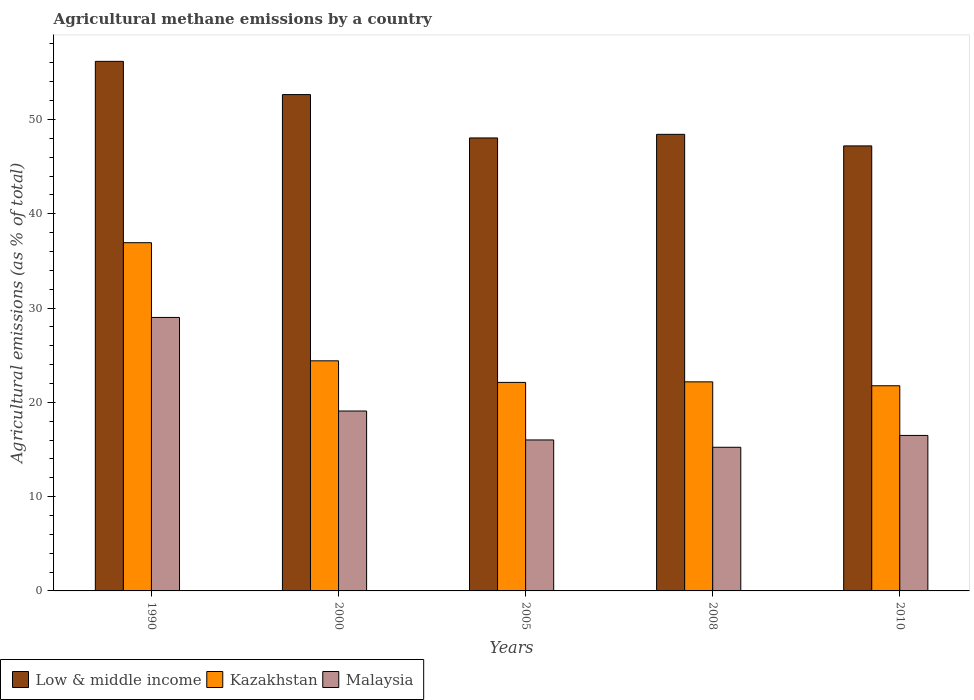How many bars are there on the 4th tick from the right?
Provide a succinct answer. 3. What is the label of the 5th group of bars from the left?
Offer a terse response. 2010. In how many cases, is the number of bars for a given year not equal to the number of legend labels?
Ensure brevity in your answer.  0. What is the amount of agricultural methane emitted in Malaysia in 2000?
Your answer should be compact. 19.08. Across all years, what is the maximum amount of agricultural methane emitted in Kazakhstan?
Offer a very short reply. 36.93. Across all years, what is the minimum amount of agricultural methane emitted in Malaysia?
Your answer should be very brief. 15.23. In which year was the amount of agricultural methane emitted in Malaysia minimum?
Give a very brief answer. 2008. What is the total amount of agricultural methane emitted in Malaysia in the graph?
Provide a short and direct response. 95.81. What is the difference between the amount of agricultural methane emitted in Kazakhstan in 1990 and that in 2005?
Offer a very short reply. 14.82. What is the difference between the amount of agricultural methane emitted in Malaysia in 2008 and the amount of agricultural methane emitted in Kazakhstan in 2010?
Make the answer very short. -6.52. What is the average amount of agricultural methane emitted in Low & middle income per year?
Offer a very short reply. 50.49. In the year 2000, what is the difference between the amount of agricultural methane emitted in Low & middle income and amount of agricultural methane emitted in Kazakhstan?
Offer a very short reply. 28.23. In how many years, is the amount of agricultural methane emitted in Low & middle income greater than 2 %?
Keep it short and to the point. 5. What is the ratio of the amount of agricultural methane emitted in Malaysia in 1990 to that in 2000?
Your answer should be very brief. 1.52. Is the amount of agricultural methane emitted in Malaysia in 1990 less than that in 2005?
Make the answer very short. No. What is the difference between the highest and the second highest amount of agricultural methane emitted in Kazakhstan?
Provide a short and direct response. 12.53. What is the difference between the highest and the lowest amount of agricultural methane emitted in Malaysia?
Give a very brief answer. 13.77. In how many years, is the amount of agricultural methane emitted in Malaysia greater than the average amount of agricultural methane emitted in Malaysia taken over all years?
Offer a terse response. 1. Is the sum of the amount of agricultural methane emitted in Low & middle income in 2005 and 2008 greater than the maximum amount of agricultural methane emitted in Kazakhstan across all years?
Give a very brief answer. Yes. What does the 3rd bar from the left in 2010 represents?
Ensure brevity in your answer.  Malaysia. What does the 2nd bar from the right in 2005 represents?
Keep it short and to the point. Kazakhstan. Is it the case that in every year, the sum of the amount of agricultural methane emitted in Malaysia and amount of agricultural methane emitted in Low & middle income is greater than the amount of agricultural methane emitted in Kazakhstan?
Provide a succinct answer. Yes. How many bars are there?
Offer a terse response. 15. Are all the bars in the graph horizontal?
Ensure brevity in your answer.  No. How many years are there in the graph?
Your answer should be compact. 5. Does the graph contain any zero values?
Offer a terse response. No. Does the graph contain grids?
Offer a terse response. No. How many legend labels are there?
Your answer should be very brief. 3. What is the title of the graph?
Make the answer very short. Agricultural methane emissions by a country. Does "High income" appear as one of the legend labels in the graph?
Keep it short and to the point. No. What is the label or title of the X-axis?
Give a very brief answer. Years. What is the label or title of the Y-axis?
Your answer should be very brief. Agricultural emissions (as % of total). What is the Agricultural emissions (as % of total) of Low & middle income in 1990?
Ensure brevity in your answer.  56.16. What is the Agricultural emissions (as % of total) in Kazakhstan in 1990?
Give a very brief answer. 36.93. What is the Agricultural emissions (as % of total) of Malaysia in 1990?
Offer a terse response. 29. What is the Agricultural emissions (as % of total) of Low & middle income in 2000?
Give a very brief answer. 52.63. What is the Agricultural emissions (as % of total) of Kazakhstan in 2000?
Offer a very short reply. 24.4. What is the Agricultural emissions (as % of total) of Malaysia in 2000?
Make the answer very short. 19.08. What is the Agricultural emissions (as % of total) of Low & middle income in 2005?
Provide a succinct answer. 48.04. What is the Agricultural emissions (as % of total) of Kazakhstan in 2005?
Provide a short and direct response. 22.11. What is the Agricultural emissions (as % of total) in Malaysia in 2005?
Give a very brief answer. 16.01. What is the Agricultural emissions (as % of total) in Low & middle income in 2008?
Give a very brief answer. 48.42. What is the Agricultural emissions (as % of total) of Kazakhstan in 2008?
Give a very brief answer. 22.17. What is the Agricultural emissions (as % of total) of Malaysia in 2008?
Your response must be concise. 15.23. What is the Agricultural emissions (as % of total) of Low & middle income in 2010?
Provide a short and direct response. 47.19. What is the Agricultural emissions (as % of total) of Kazakhstan in 2010?
Ensure brevity in your answer.  21.76. What is the Agricultural emissions (as % of total) of Malaysia in 2010?
Make the answer very short. 16.49. Across all years, what is the maximum Agricultural emissions (as % of total) of Low & middle income?
Ensure brevity in your answer.  56.16. Across all years, what is the maximum Agricultural emissions (as % of total) of Kazakhstan?
Offer a very short reply. 36.93. Across all years, what is the maximum Agricultural emissions (as % of total) in Malaysia?
Your answer should be compact. 29. Across all years, what is the minimum Agricultural emissions (as % of total) of Low & middle income?
Your answer should be very brief. 47.19. Across all years, what is the minimum Agricultural emissions (as % of total) of Kazakhstan?
Your answer should be very brief. 21.76. Across all years, what is the minimum Agricultural emissions (as % of total) of Malaysia?
Ensure brevity in your answer.  15.23. What is the total Agricultural emissions (as % of total) in Low & middle income in the graph?
Give a very brief answer. 252.44. What is the total Agricultural emissions (as % of total) in Kazakhstan in the graph?
Make the answer very short. 127.37. What is the total Agricultural emissions (as % of total) of Malaysia in the graph?
Make the answer very short. 95.81. What is the difference between the Agricultural emissions (as % of total) in Low & middle income in 1990 and that in 2000?
Your answer should be compact. 3.52. What is the difference between the Agricultural emissions (as % of total) in Kazakhstan in 1990 and that in 2000?
Your answer should be compact. 12.53. What is the difference between the Agricultural emissions (as % of total) in Malaysia in 1990 and that in 2000?
Ensure brevity in your answer.  9.92. What is the difference between the Agricultural emissions (as % of total) of Low & middle income in 1990 and that in 2005?
Offer a very short reply. 8.12. What is the difference between the Agricultural emissions (as % of total) of Kazakhstan in 1990 and that in 2005?
Offer a terse response. 14.82. What is the difference between the Agricultural emissions (as % of total) of Malaysia in 1990 and that in 2005?
Provide a short and direct response. 12.99. What is the difference between the Agricultural emissions (as % of total) of Low & middle income in 1990 and that in 2008?
Give a very brief answer. 7.74. What is the difference between the Agricultural emissions (as % of total) of Kazakhstan in 1990 and that in 2008?
Your answer should be very brief. 14.76. What is the difference between the Agricultural emissions (as % of total) in Malaysia in 1990 and that in 2008?
Provide a succinct answer. 13.77. What is the difference between the Agricultural emissions (as % of total) in Low & middle income in 1990 and that in 2010?
Your response must be concise. 8.97. What is the difference between the Agricultural emissions (as % of total) of Kazakhstan in 1990 and that in 2010?
Give a very brief answer. 15.17. What is the difference between the Agricultural emissions (as % of total) in Malaysia in 1990 and that in 2010?
Keep it short and to the point. 12.51. What is the difference between the Agricultural emissions (as % of total) of Low & middle income in 2000 and that in 2005?
Keep it short and to the point. 4.6. What is the difference between the Agricultural emissions (as % of total) in Kazakhstan in 2000 and that in 2005?
Your answer should be very brief. 2.29. What is the difference between the Agricultural emissions (as % of total) of Malaysia in 2000 and that in 2005?
Provide a short and direct response. 3.07. What is the difference between the Agricultural emissions (as % of total) in Low & middle income in 2000 and that in 2008?
Provide a short and direct response. 4.22. What is the difference between the Agricultural emissions (as % of total) in Kazakhstan in 2000 and that in 2008?
Provide a succinct answer. 2.23. What is the difference between the Agricultural emissions (as % of total) in Malaysia in 2000 and that in 2008?
Make the answer very short. 3.85. What is the difference between the Agricultural emissions (as % of total) of Low & middle income in 2000 and that in 2010?
Your answer should be very brief. 5.44. What is the difference between the Agricultural emissions (as % of total) of Kazakhstan in 2000 and that in 2010?
Give a very brief answer. 2.64. What is the difference between the Agricultural emissions (as % of total) of Malaysia in 2000 and that in 2010?
Offer a very short reply. 2.59. What is the difference between the Agricultural emissions (as % of total) of Low & middle income in 2005 and that in 2008?
Provide a short and direct response. -0.38. What is the difference between the Agricultural emissions (as % of total) of Kazakhstan in 2005 and that in 2008?
Give a very brief answer. -0.06. What is the difference between the Agricultural emissions (as % of total) in Malaysia in 2005 and that in 2008?
Offer a very short reply. 0.78. What is the difference between the Agricultural emissions (as % of total) in Low & middle income in 2005 and that in 2010?
Give a very brief answer. 0.84. What is the difference between the Agricultural emissions (as % of total) of Kazakhstan in 2005 and that in 2010?
Give a very brief answer. 0.36. What is the difference between the Agricultural emissions (as % of total) in Malaysia in 2005 and that in 2010?
Provide a succinct answer. -0.48. What is the difference between the Agricultural emissions (as % of total) in Low & middle income in 2008 and that in 2010?
Make the answer very short. 1.23. What is the difference between the Agricultural emissions (as % of total) in Kazakhstan in 2008 and that in 2010?
Your answer should be very brief. 0.41. What is the difference between the Agricultural emissions (as % of total) of Malaysia in 2008 and that in 2010?
Ensure brevity in your answer.  -1.26. What is the difference between the Agricultural emissions (as % of total) of Low & middle income in 1990 and the Agricultural emissions (as % of total) of Kazakhstan in 2000?
Give a very brief answer. 31.76. What is the difference between the Agricultural emissions (as % of total) of Low & middle income in 1990 and the Agricultural emissions (as % of total) of Malaysia in 2000?
Your response must be concise. 37.08. What is the difference between the Agricultural emissions (as % of total) in Kazakhstan in 1990 and the Agricultural emissions (as % of total) in Malaysia in 2000?
Provide a succinct answer. 17.85. What is the difference between the Agricultural emissions (as % of total) of Low & middle income in 1990 and the Agricultural emissions (as % of total) of Kazakhstan in 2005?
Keep it short and to the point. 34.05. What is the difference between the Agricultural emissions (as % of total) in Low & middle income in 1990 and the Agricultural emissions (as % of total) in Malaysia in 2005?
Keep it short and to the point. 40.15. What is the difference between the Agricultural emissions (as % of total) of Kazakhstan in 1990 and the Agricultural emissions (as % of total) of Malaysia in 2005?
Offer a very short reply. 20.92. What is the difference between the Agricultural emissions (as % of total) in Low & middle income in 1990 and the Agricultural emissions (as % of total) in Kazakhstan in 2008?
Offer a very short reply. 33.99. What is the difference between the Agricultural emissions (as % of total) in Low & middle income in 1990 and the Agricultural emissions (as % of total) in Malaysia in 2008?
Keep it short and to the point. 40.93. What is the difference between the Agricultural emissions (as % of total) in Kazakhstan in 1990 and the Agricultural emissions (as % of total) in Malaysia in 2008?
Your answer should be compact. 21.69. What is the difference between the Agricultural emissions (as % of total) in Low & middle income in 1990 and the Agricultural emissions (as % of total) in Kazakhstan in 2010?
Give a very brief answer. 34.4. What is the difference between the Agricultural emissions (as % of total) of Low & middle income in 1990 and the Agricultural emissions (as % of total) of Malaysia in 2010?
Provide a succinct answer. 39.67. What is the difference between the Agricultural emissions (as % of total) in Kazakhstan in 1990 and the Agricultural emissions (as % of total) in Malaysia in 2010?
Your response must be concise. 20.44. What is the difference between the Agricultural emissions (as % of total) in Low & middle income in 2000 and the Agricultural emissions (as % of total) in Kazakhstan in 2005?
Ensure brevity in your answer.  30.52. What is the difference between the Agricultural emissions (as % of total) in Low & middle income in 2000 and the Agricultural emissions (as % of total) in Malaysia in 2005?
Your answer should be compact. 36.62. What is the difference between the Agricultural emissions (as % of total) of Kazakhstan in 2000 and the Agricultural emissions (as % of total) of Malaysia in 2005?
Keep it short and to the point. 8.39. What is the difference between the Agricultural emissions (as % of total) in Low & middle income in 2000 and the Agricultural emissions (as % of total) in Kazakhstan in 2008?
Your answer should be compact. 30.46. What is the difference between the Agricultural emissions (as % of total) of Low & middle income in 2000 and the Agricultural emissions (as % of total) of Malaysia in 2008?
Provide a short and direct response. 37.4. What is the difference between the Agricultural emissions (as % of total) in Kazakhstan in 2000 and the Agricultural emissions (as % of total) in Malaysia in 2008?
Give a very brief answer. 9.17. What is the difference between the Agricultural emissions (as % of total) in Low & middle income in 2000 and the Agricultural emissions (as % of total) in Kazakhstan in 2010?
Your response must be concise. 30.88. What is the difference between the Agricultural emissions (as % of total) of Low & middle income in 2000 and the Agricultural emissions (as % of total) of Malaysia in 2010?
Give a very brief answer. 36.15. What is the difference between the Agricultural emissions (as % of total) of Kazakhstan in 2000 and the Agricultural emissions (as % of total) of Malaysia in 2010?
Make the answer very short. 7.91. What is the difference between the Agricultural emissions (as % of total) in Low & middle income in 2005 and the Agricultural emissions (as % of total) in Kazakhstan in 2008?
Your answer should be compact. 25.87. What is the difference between the Agricultural emissions (as % of total) in Low & middle income in 2005 and the Agricultural emissions (as % of total) in Malaysia in 2008?
Ensure brevity in your answer.  32.8. What is the difference between the Agricultural emissions (as % of total) in Kazakhstan in 2005 and the Agricultural emissions (as % of total) in Malaysia in 2008?
Provide a short and direct response. 6.88. What is the difference between the Agricultural emissions (as % of total) in Low & middle income in 2005 and the Agricultural emissions (as % of total) in Kazakhstan in 2010?
Provide a short and direct response. 26.28. What is the difference between the Agricultural emissions (as % of total) of Low & middle income in 2005 and the Agricultural emissions (as % of total) of Malaysia in 2010?
Your answer should be compact. 31.55. What is the difference between the Agricultural emissions (as % of total) of Kazakhstan in 2005 and the Agricultural emissions (as % of total) of Malaysia in 2010?
Make the answer very short. 5.62. What is the difference between the Agricultural emissions (as % of total) in Low & middle income in 2008 and the Agricultural emissions (as % of total) in Kazakhstan in 2010?
Give a very brief answer. 26.66. What is the difference between the Agricultural emissions (as % of total) of Low & middle income in 2008 and the Agricultural emissions (as % of total) of Malaysia in 2010?
Provide a short and direct response. 31.93. What is the difference between the Agricultural emissions (as % of total) of Kazakhstan in 2008 and the Agricultural emissions (as % of total) of Malaysia in 2010?
Keep it short and to the point. 5.68. What is the average Agricultural emissions (as % of total) in Low & middle income per year?
Provide a short and direct response. 50.49. What is the average Agricultural emissions (as % of total) in Kazakhstan per year?
Provide a short and direct response. 25.47. What is the average Agricultural emissions (as % of total) in Malaysia per year?
Provide a succinct answer. 19.16. In the year 1990, what is the difference between the Agricultural emissions (as % of total) in Low & middle income and Agricultural emissions (as % of total) in Kazakhstan?
Your answer should be very brief. 19.23. In the year 1990, what is the difference between the Agricultural emissions (as % of total) of Low & middle income and Agricultural emissions (as % of total) of Malaysia?
Your answer should be very brief. 27.16. In the year 1990, what is the difference between the Agricultural emissions (as % of total) of Kazakhstan and Agricultural emissions (as % of total) of Malaysia?
Offer a very short reply. 7.93. In the year 2000, what is the difference between the Agricultural emissions (as % of total) in Low & middle income and Agricultural emissions (as % of total) in Kazakhstan?
Offer a terse response. 28.23. In the year 2000, what is the difference between the Agricultural emissions (as % of total) of Low & middle income and Agricultural emissions (as % of total) of Malaysia?
Give a very brief answer. 33.56. In the year 2000, what is the difference between the Agricultural emissions (as % of total) of Kazakhstan and Agricultural emissions (as % of total) of Malaysia?
Give a very brief answer. 5.32. In the year 2005, what is the difference between the Agricultural emissions (as % of total) in Low & middle income and Agricultural emissions (as % of total) in Kazakhstan?
Make the answer very short. 25.92. In the year 2005, what is the difference between the Agricultural emissions (as % of total) of Low & middle income and Agricultural emissions (as % of total) of Malaysia?
Provide a succinct answer. 32.03. In the year 2005, what is the difference between the Agricultural emissions (as % of total) of Kazakhstan and Agricultural emissions (as % of total) of Malaysia?
Ensure brevity in your answer.  6.1. In the year 2008, what is the difference between the Agricultural emissions (as % of total) of Low & middle income and Agricultural emissions (as % of total) of Kazakhstan?
Your answer should be very brief. 26.25. In the year 2008, what is the difference between the Agricultural emissions (as % of total) in Low & middle income and Agricultural emissions (as % of total) in Malaysia?
Provide a short and direct response. 33.19. In the year 2008, what is the difference between the Agricultural emissions (as % of total) of Kazakhstan and Agricultural emissions (as % of total) of Malaysia?
Ensure brevity in your answer.  6.94. In the year 2010, what is the difference between the Agricultural emissions (as % of total) of Low & middle income and Agricultural emissions (as % of total) of Kazakhstan?
Ensure brevity in your answer.  25.43. In the year 2010, what is the difference between the Agricultural emissions (as % of total) of Low & middle income and Agricultural emissions (as % of total) of Malaysia?
Your answer should be compact. 30.7. In the year 2010, what is the difference between the Agricultural emissions (as % of total) of Kazakhstan and Agricultural emissions (as % of total) of Malaysia?
Offer a terse response. 5.27. What is the ratio of the Agricultural emissions (as % of total) in Low & middle income in 1990 to that in 2000?
Your answer should be compact. 1.07. What is the ratio of the Agricultural emissions (as % of total) in Kazakhstan in 1990 to that in 2000?
Your answer should be very brief. 1.51. What is the ratio of the Agricultural emissions (as % of total) of Malaysia in 1990 to that in 2000?
Offer a very short reply. 1.52. What is the ratio of the Agricultural emissions (as % of total) of Low & middle income in 1990 to that in 2005?
Your response must be concise. 1.17. What is the ratio of the Agricultural emissions (as % of total) in Kazakhstan in 1990 to that in 2005?
Provide a succinct answer. 1.67. What is the ratio of the Agricultural emissions (as % of total) in Malaysia in 1990 to that in 2005?
Make the answer very short. 1.81. What is the ratio of the Agricultural emissions (as % of total) of Low & middle income in 1990 to that in 2008?
Ensure brevity in your answer.  1.16. What is the ratio of the Agricultural emissions (as % of total) in Kazakhstan in 1990 to that in 2008?
Give a very brief answer. 1.67. What is the ratio of the Agricultural emissions (as % of total) in Malaysia in 1990 to that in 2008?
Your answer should be compact. 1.9. What is the ratio of the Agricultural emissions (as % of total) in Low & middle income in 1990 to that in 2010?
Your response must be concise. 1.19. What is the ratio of the Agricultural emissions (as % of total) of Kazakhstan in 1990 to that in 2010?
Give a very brief answer. 1.7. What is the ratio of the Agricultural emissions (as % of total) of Malaysia in 1990 to that in 2010?
Provide a succinct answer. 1.76. What is the ratio of the Agricultural emissions (as % of total) in Low & middle income in 2000 to that in 2005?
Give a very brief answer. 1.1. What is the ratio of the Agricultural emissions (as % of total) of Kazakhstan in 2000 to that in 2005?
Your answer should be compact. 1.1. What is the ratio of the Agricultural emissions (as % of total) of Malaysia in 2000 to that in 2005?
Give a very brief answer. 1.19. What is the ratio of the Agricultural emissions (as % of total) in Low & middle income in 2000 to that in 2008?
Offer a very short reply. 1.09. What is the ratio of the Agricultural emissions (as % of total) of Kazakhstan in 2000 to that in 2008?
Provide a short and direct response. 1.1. What is the ratio of the Agricultural emissions (as % of total) in Malaysia in 2000 to that in 2008?
Your answer should be compact. 1.25. What is the ratio of the Agricultural emissions (as % of total) of Low & middle income in 2000 to that in 2010?
Ensure brevity in your answer.  1.12. What is the ratio of the Agricultural emissions (as % of total) in Kazakhstan in 2000 to that in 2010?
Offer a terse response. 1.12. What is the ratio of the Agricultural emissions (as % of total) of Malaysia in 2000 to that in 2010?
Your response must be concise. 1.16. What is the ratio of the Agricultural emissions (as % of total) of Low & middle income in 2005 to that in 2008?
Keep it short and to the point. 0.99. What is the ratio of the Agricultural emissions (as % of total) in Malaysia in 2005 to that in 2008?
Give a very brief answer. 1.05. What is the ratio of the Agricultural emissions (as % of total) in Low & middle income in 2005 to that in 2010?
Offer a very short reply. 1.02. What is the ratio of the Agricultural emissions (as % of total) of Kazakhstan in 2005 to that in 2010?
Your answer should be compact. 1.02. What is the ratio of the Agricultural emissions (as % of total) of Low & middle income in 2008 to that in 2010?
Offer a very short reply. 1.03. What is the ratio of the Agricultural emissions (as % of total) in Kazakhstan in 2008 to that in 2010?
Give a very brief answer. 1.02. What is the ratio of the Agricultural emissions (as % of total) of Malaysia in 2008 to that in 2010?
Make the answer very short. 0.92. What is the difference between the highest and the second highest Agricultural emissions (as % of total) in Low & middle income?
Offer a very short reply. 3.52. What is the difference between the highest and the second highest Agricultural emissions (as % of total) in Kazakhstan?
Ensure brevity in your answer.  12.53. What is the difference between the highest and the second highest Agricultural emissions (as % of total) of Malaysia?
Your answer should be very brief. 9.92. What is the difference between the highest and the lowest Agricultural emissions (as % of total) of Low & middle income?
Provide a short and direct response. 8.97. What is the difference between the highest and the lowest Agricultural emissions (as % of total) in Kazakhstan?
Your response must be concise. 15.17. What is the difference between the highest and the lowest Agricultural emissions (as % of total) in Malaysia?
Make the answer very short. 13.77. 